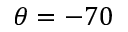Convert formula to latex. <formula><loc_0><loc_0><loc_500><loc_500>\theta = - 7 0</formula> 